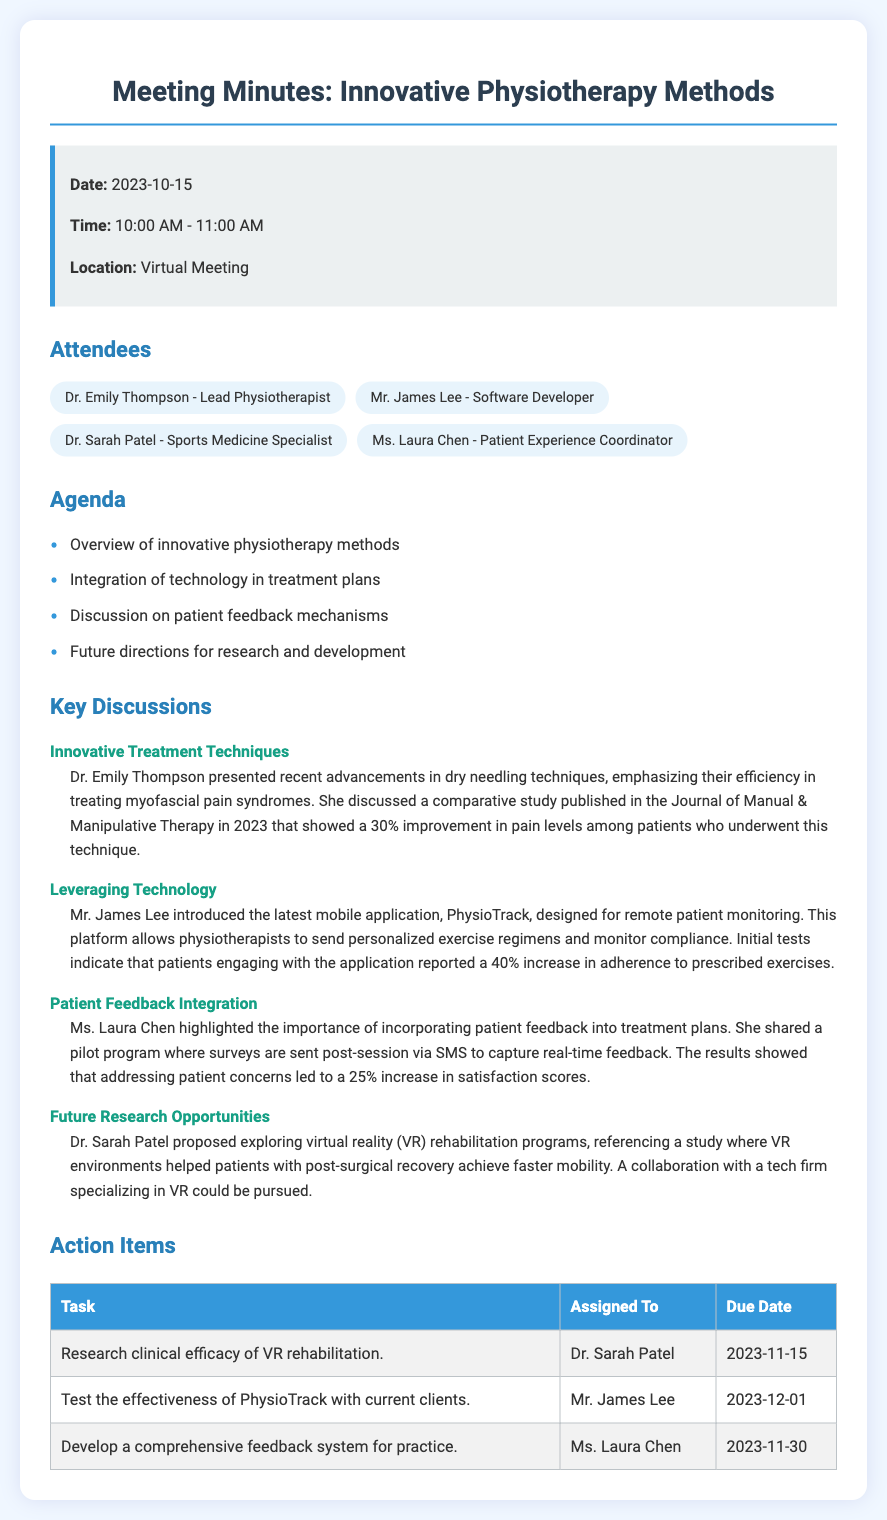what date was the meeting held? The document states the meeting date as “2023-10-15”.
Answer: 2023-10-15 who introduced the mobile application PhysioTrack? The document mentions Mr. James Lee as the individual who introduced PhysioTrack.
Answer: Mr. James Lee what was the improvement percentage in pain levels from dry needling techniques? The document indicates a 30% improvement in pain levels among patients who underwent dry needling.
Answer: 30% how many attendees were present at the meeting? The document lists four attendees participating in the meeting.
Answer: 4 what is the due date for researching the clinical efficacy of VR rehabilitation? The action item states the due date as “2023-11-15”.
Answer: 2023-11-15 which attendee highlighted the importance of patient feedback integration? Ms. Laura Chen is identified in the document as the one highlighting the importance of patient feedback.
Answer: Ms. Laura Chen what percentage increase in satisfaction scores was reported after addressing patient concerns? The document notes a 25% increase in satisfaction scores after addressing patient feedback.
Answer: 25% what action item is assigned to Mr. James Lee? The document mentions that Mr. James Lee is tasked with testing the effectiveness of PhysioTrack.
Answer: Test the effectiveness of PhysioTrack with current clients 